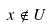Convert formula to latex. <formula><loc_0><loc_0><loc_500><loc_500>x \notin U</formula> 